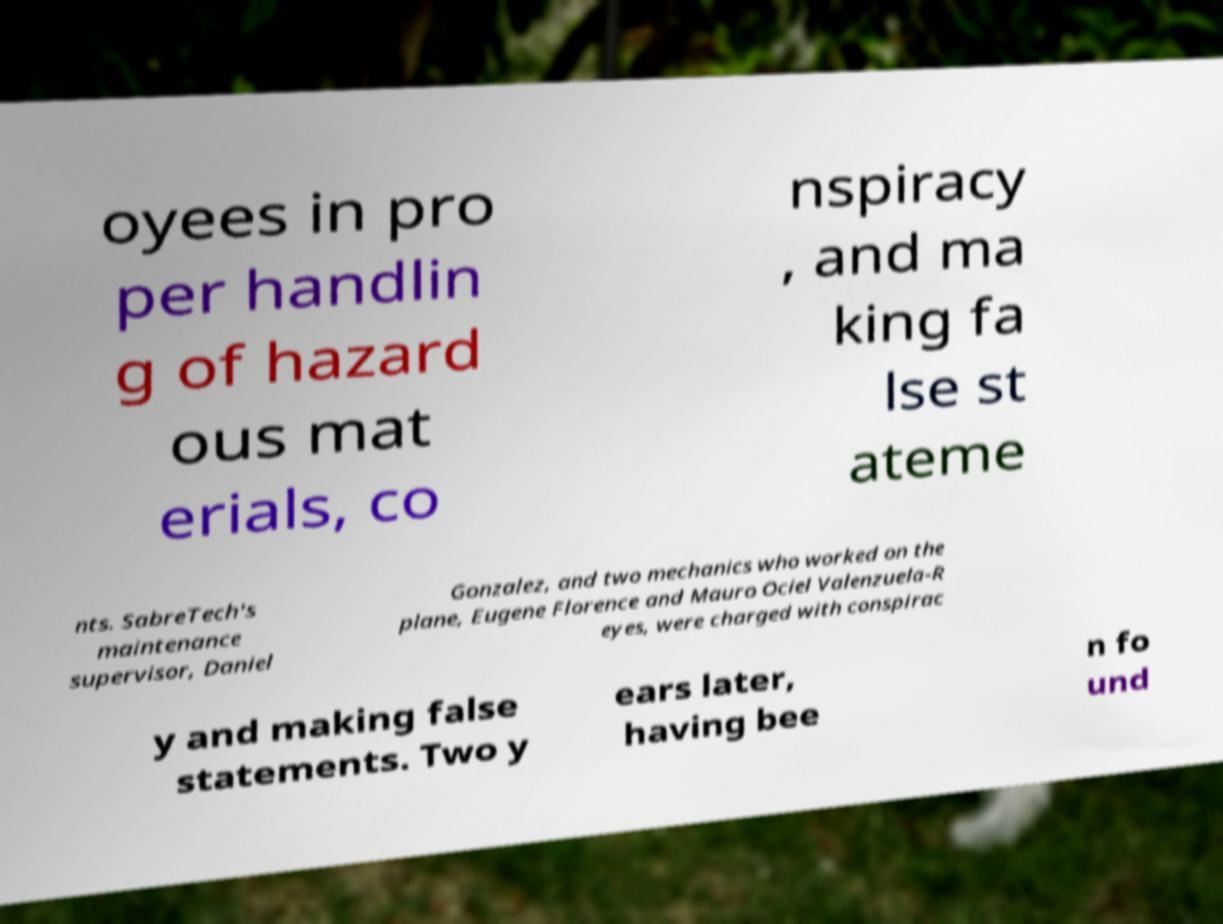For documentation purposes, I need the text within this image transcribed. Could you provide that? oyees in pro per handlin g of hazard ous mat erials, co nspiracy , and ma king fa lse st ateme nts. SabreTech's maintenance supervisor, Daniel Gonzalez, and two mechanics who worked on the plane, Eugene Florence and Mauro Ociel Valenzuela-R eyes, were charged with conspirac y and making false statements. Two y ears later, having bee n fo und 